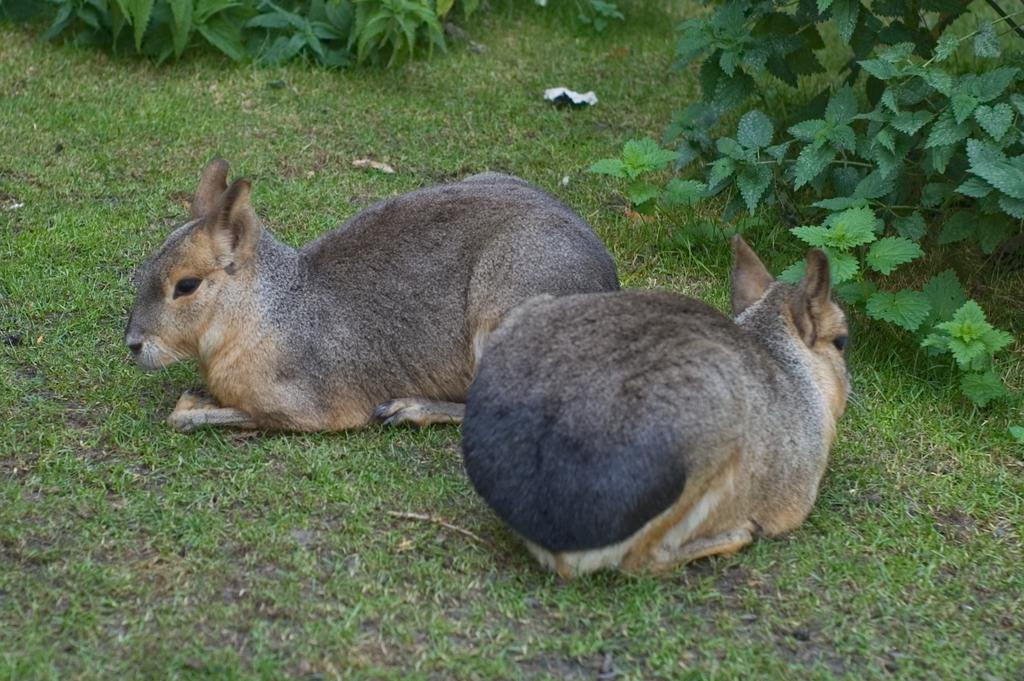What animals are in the center of the image? There are rabbits in the center of the image. What can be seen in the background of the image? There are plants in the background of the image. What type of yam is growing on the wall in the image? There is no yam or wall present in the image; it features rabbits and plants. 